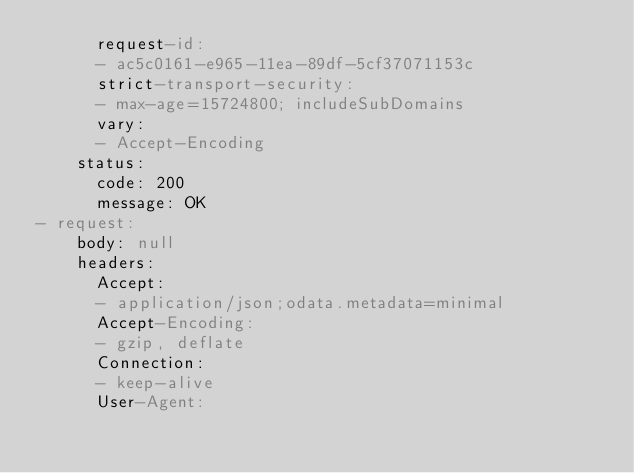Convert code to text. <code><loc_0><loc_0><loc_500><loc_500><_YAML_>      request-id:
      - ac5c0161-e965-11ea-89df-5cf37071153c
      strict-transport-security:
      - max-age=15724800; includeSubDomains
      vary:
      - Accept-Encoding
    status:
      code: 200
      message: OK
- request:
    body: null
    headers:
      Accept:
      - application/json;odata.metadata=minimal
      Accept-Encoding:
      - gzip, deflate
      Connection:
      - keep-alive
      User-Agent:</code> 